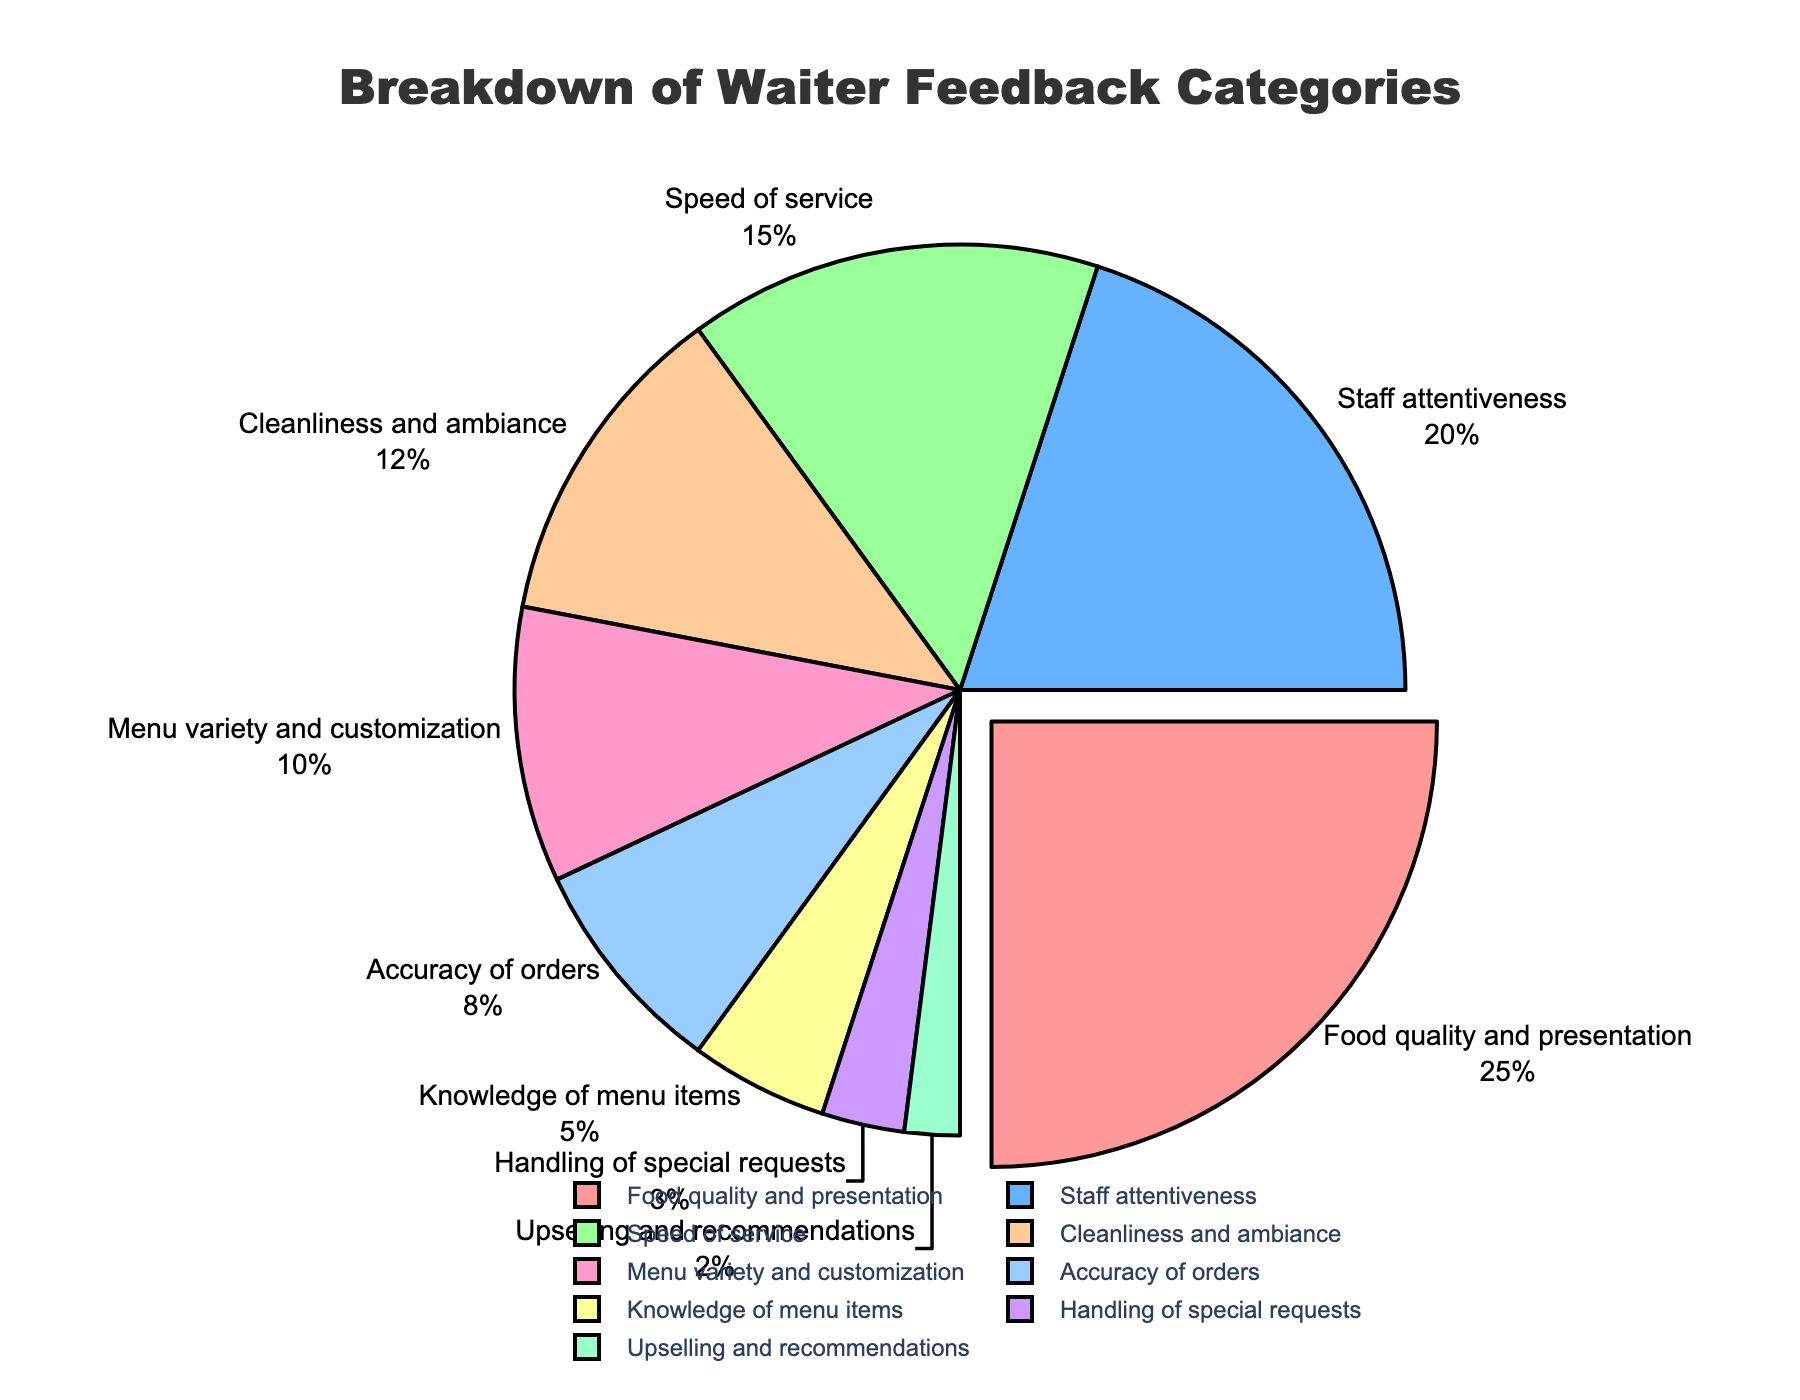What's the category with the highest feedback percentage? First, look at the pie chart for segments and their corresponding percentages. "Food quality and presentation" has the biggest segment with 25%.
Answer: Food quality and presentation Which two categories combined constitute 35% of the feedback? Identify the percentages for each category and find a combination that sums to 35%. "Staff attentiveness" (20%) and "Speed of service" (15%) add up to 35%.
Answer: Staff attentiveness and Speed of service Is the percentage of "Menu variety and customization" higher or lower than "Cleanliness and ambiance"? Compare the percentages for both categories directly. "Menu variety and customization" is 10% and "Cleanliness and ambiance" is 12%.
Answer: Lower What is the total percentage of feedback for categories related to order accuracy and special requests handling? Sum the percentages for "Accuracy of orders" (8%) and "Handling of special requests" (3%). 8% + 3% = 11%.
Answer: 11% Which categories together account for less than 20% of the feedback? Identify categories whose percentages sum to less than 20%. "Knowledge of menu items" (5%), "Handling of special requests" (3%), and "Upselling and recommendations" (2%) together are 5% + 3% + 2% = 10%.
Answer: Knowledge of menu items, Handling of special requests, and Upselling and recommendations How much higher is the percentage of "Food quality and presentation" than "Staff attentiveness"? Subtract "Staff attentiveness" percentage from "Food quality and presentation". 25% - 20% = 5%.
Answer: 5% In terms of feedback percentage, how does "Speed of service" compare to "Cleanliness and ambiance"? Compare the two percentages directly: "Speed of service" is 15%, and "Cleanliness and ambiance" is 12%.
Answer: Higher What feedback categories are highlighted visually by pulling out of the pie chart? Observe the pie chart to see which segment is pulled outward. The "Food quality and presentation" segment is visually pulled out.
Answer: Food quality and presentation 